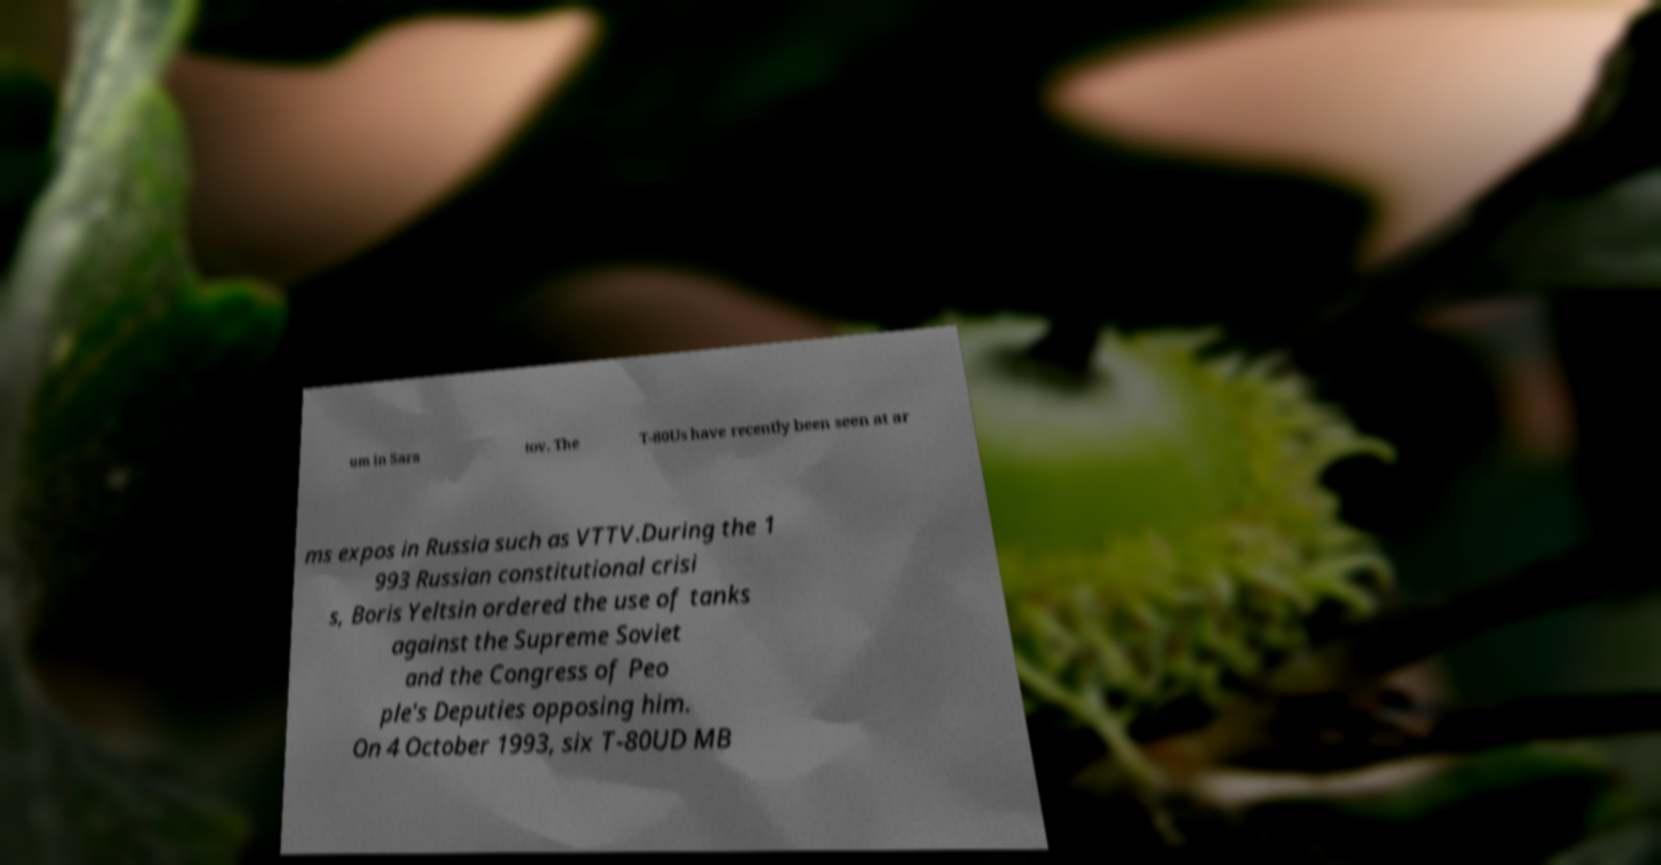Could you assist in decoding the text presented in this image and type it out clearly? um in Sara tov. The T-80Us have recently been seen at ar ms expos in Russia such as VTTV.During the 1 993 Russian constitutional crisi s, Boris Yeltsin ordered the use of tanks against the Supreme Soviet and the Congress of Peo ple's Deputies opposing him. On 4 October 1993, six T-80UD MB 